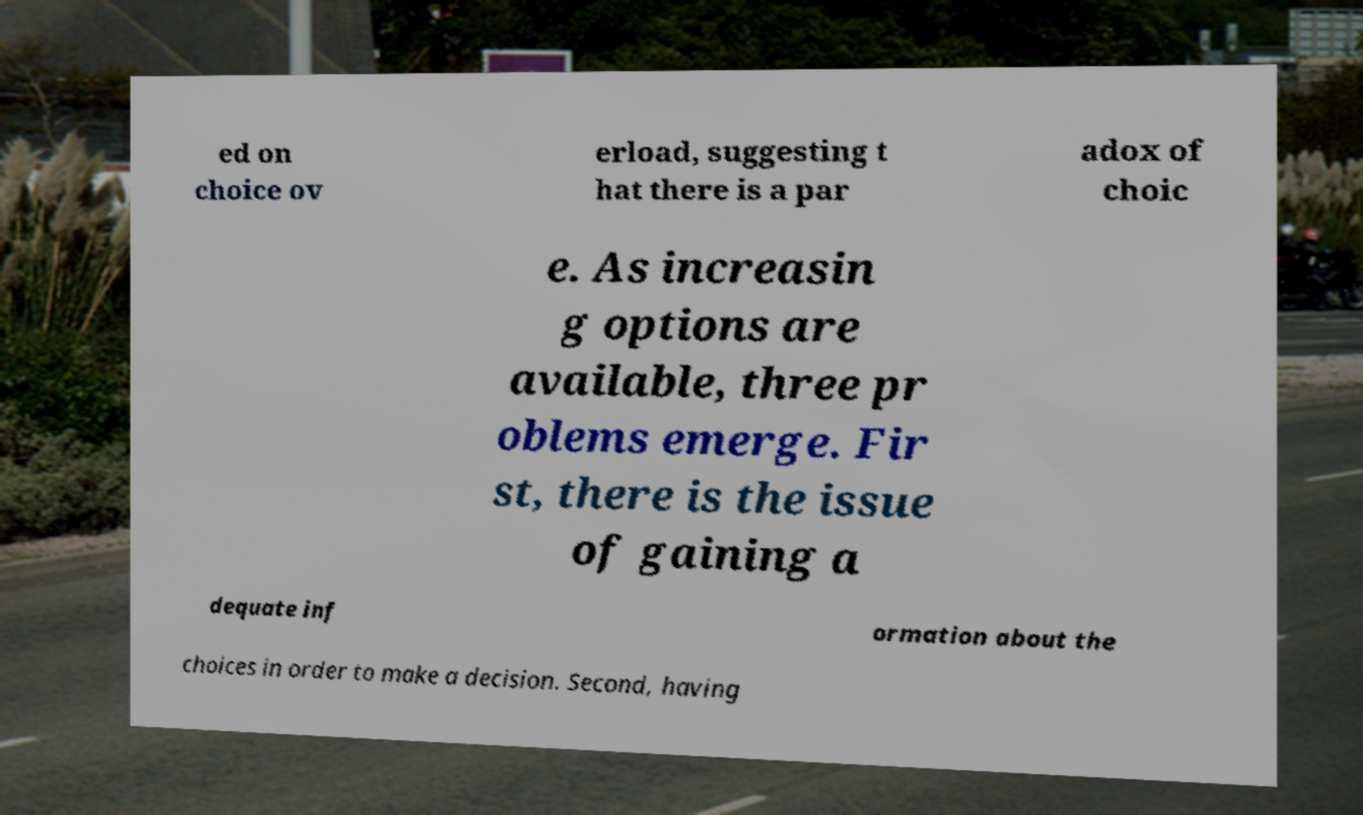What messages or text are displayed in this image? I need them in a readable, typed format. ed on choice ov erload, suggesting t hat there is a par adox of choic e. As increasin g options are available, three pr oblems emerge. Fir st, there is the issue of gaining a dequate inf ormation about the choices in order to make a decision. Second, having 